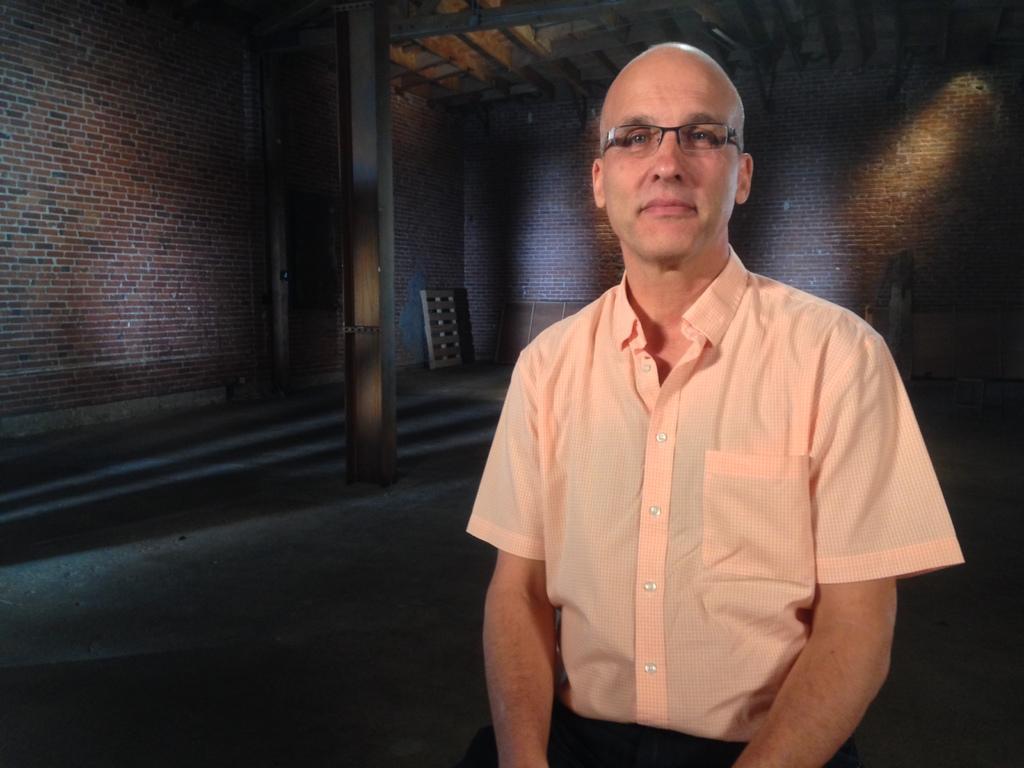Could you give a brief overview of what you see in this image? There is a person sitting and wore spectacle. In the background we can see walls, pillar and objects. 